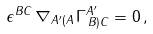<formula> <loc_0><loc_0><loc_500><loc_500>\epsilon ^ { B C } \, \nabla _ { A ^ { \prime } ( A } \, \Gamma _ { \, B ) C } ^ { A ^ { \prime } } = 0 \, ,</formula> 